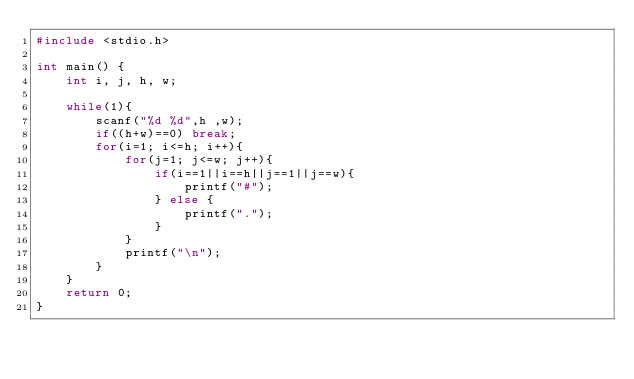Convert code to text. <code><loc_0><loc_0><loc_500><loc_500><_C_>#include <stdio.h>

int main() {
    int i, j, h, w;
    
    while(1){
        scanf("%d %d",h ,w);
        if((h+w)==0) break;
        for(i=1; i<=h; i++){
            for(j=1; j<=w; j++){
                if(i==1||i==h||j==1||j==w){
                    printf("#");
                } else {
                    printf(".");
                }
            }
            printf("\n");
        }
    }
    return 0;
}
</code> 